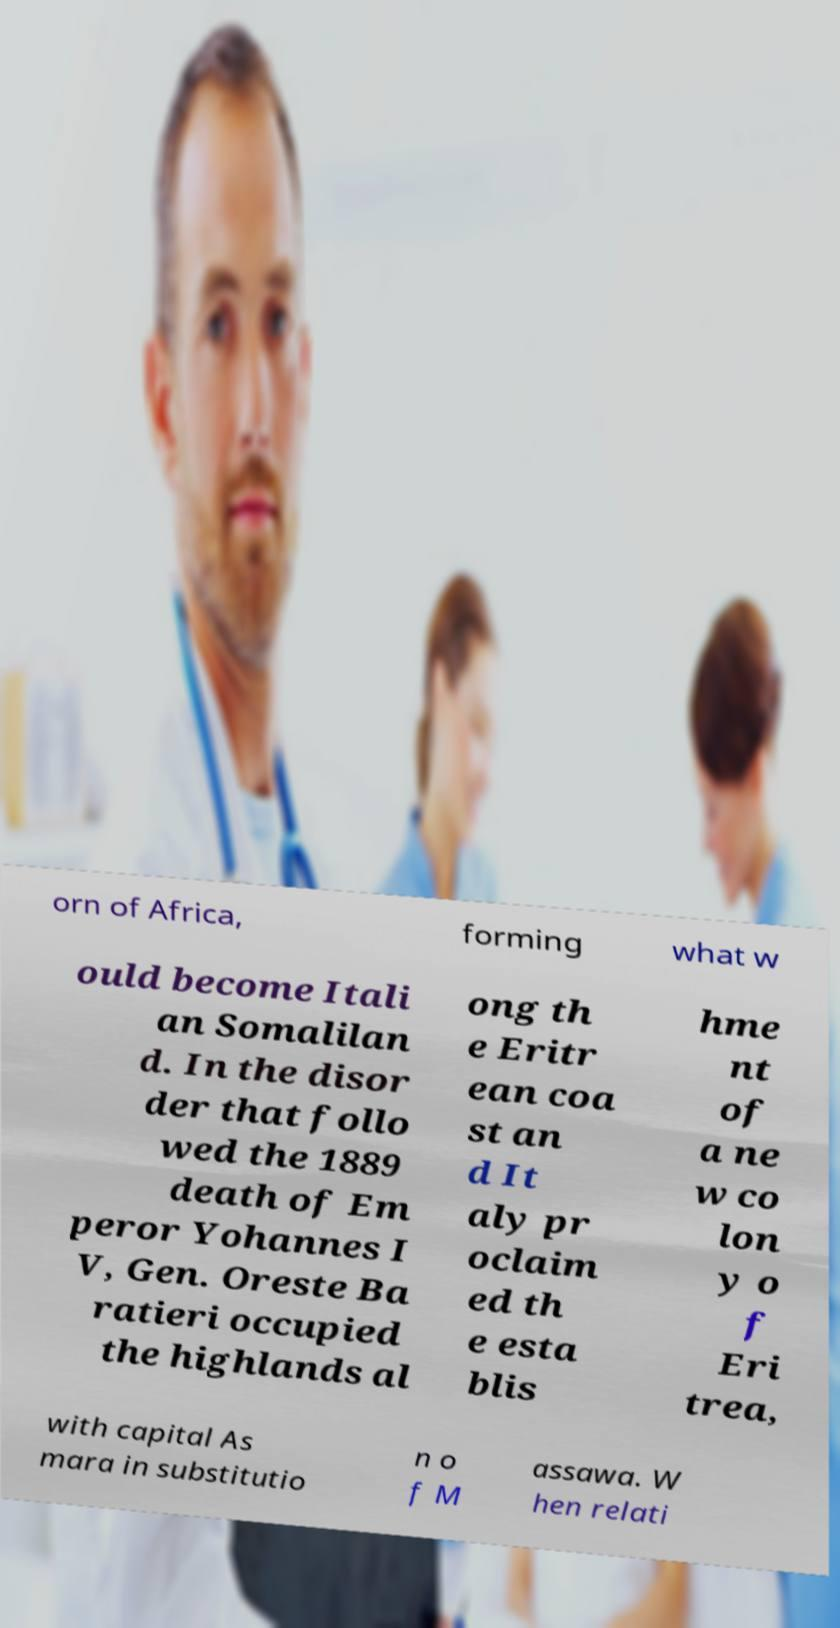Please identify and transcribe the text found in this image. orn of Africa, forming what w ould become Itali an Somalilan d. In the disor der that follo wed the 1889 death of Em peror Yohannes I V, Gen. Oreste Ba ratieri occupied the highlands al ong th e Eritr ean coa st an d It aly pr oclaim ed th e esta blis hme nt of a ne w co lon y o f Eri trea, with capital As mara in substitutio n o f M assawa. W hen relati 